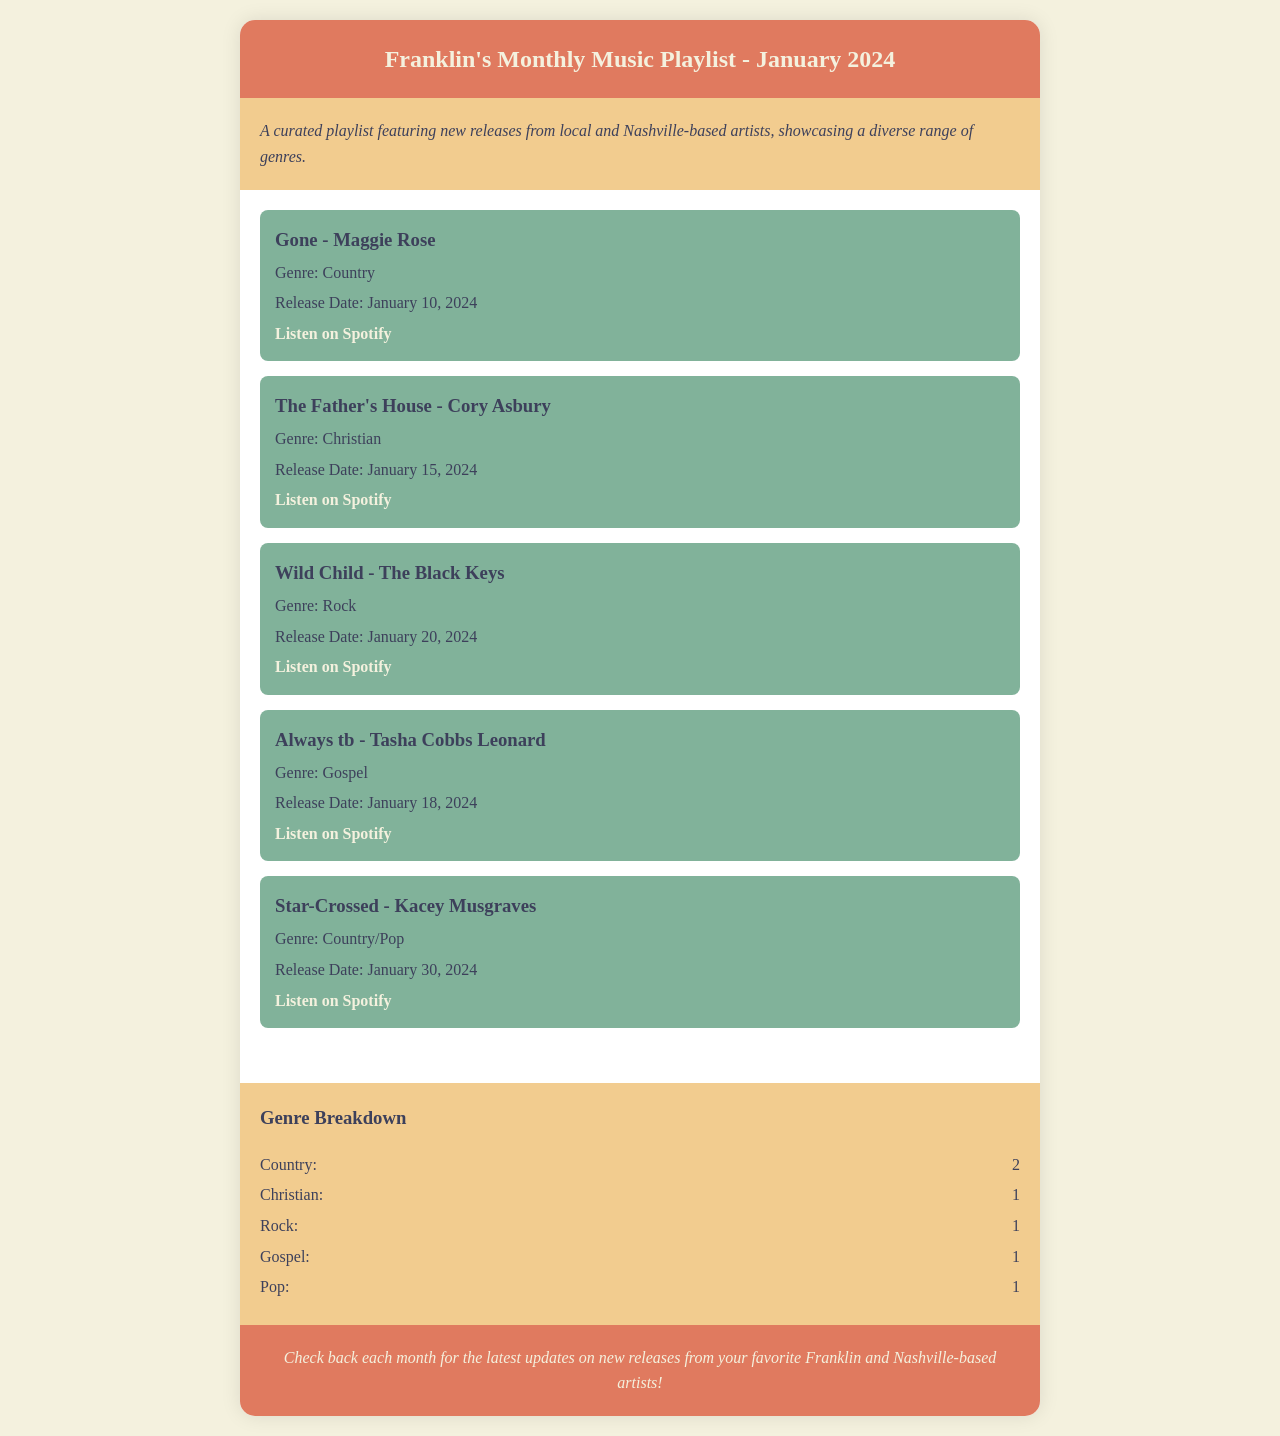What is the title of the playlist? The title is stated at the top of the document under the header section.
Answer: Franklin's Monthly Music Playlist - January 2024 How many songs are listed in the playlist? The document provides a list of songs in the playlist, specifically counting each song mentioned.
Answer: 5 What genre does "Gone" belong to? The genre of the song "Gone" is specified under its details in the playlist.
Answer: Country What is the release date of "The Father's House"? The release date is provided with the song details in the playlist.
Answer: January 15, 2024 How many genres are listed in the genre breakdown? The number of unique genres is counted from the genre breakdown section in the document.
Answer: 5 Which artist performed "Star-Crossed"? The artist's name is mentioned alongside the song title in the playlist.
Answer: Kacey Musgraves What is the total number of Country songs in the playlist? The genre breakdown indicates the number of Country songs specifically listed.
Answer: 2 Which song has the release date of January 30, 2024? The specific release date connects to the title of the song mentioned in the playlist.
Answer: Star-Crossed How many songs fall under the Christian genre? The genre breakdown quantifies the number of songs categorized as Christian.
Answer: 1 